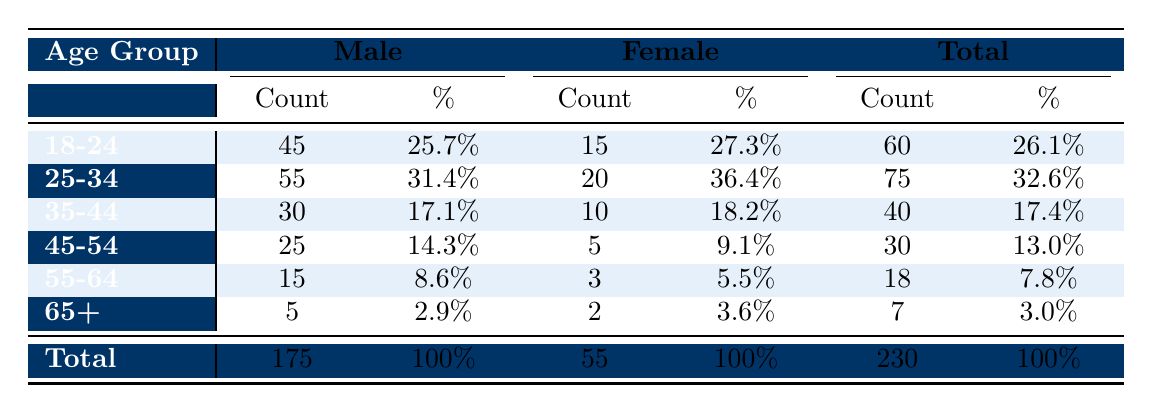What is the total number of surgeries required for males aged 25-34? The table shows the count for males in the 25-34 age group is 55.
Answer: 55 What percentage of total surgeries were performed on females? To find the percentage of surgeries performed on females, divide the total count of female surgeries (55) by the total count of surgeries (230) and multiply by 100: (55/230) * 100 = 23.9%.
Answer: 23.9% What age group has the highest number of surgeries required for females? Comparing the counts for each female age group, 20 for 25-34 is the highest, followed by 15 for 18-24.
Answer: 25-34 Is the number of surgeries for males in the 35-44 age group greater than for females in the same age group? Male surgeries in the 35-44 age group are 30, while female surgeries are 10. Since 30 > 10, the statement is true.
Answer: Yes What is the difference between the number of surgeries for males aged 18-24 and those aged 45-54? The number of surgeries for males aged 18-24 is 45, and for 45-54 it is 25. The difference is 45 - 25 = 20.
Answer: 20 What is the total count of surgeries required for the age group of 55-64? The table states that for the 55-64 age group, the total count is 18 (15 males and 3 females).
Answer: 18 What is the average percentage of surgeries across all age groups for females? Adding the percentages for females: 27.3% + 36.4% + 18.2% + 9.1% + 5.5% + 3.6% = 100%, and dividing by 6 (the number of age groups) gives the average percentage of 16.67%.
Answer: 16.67% 